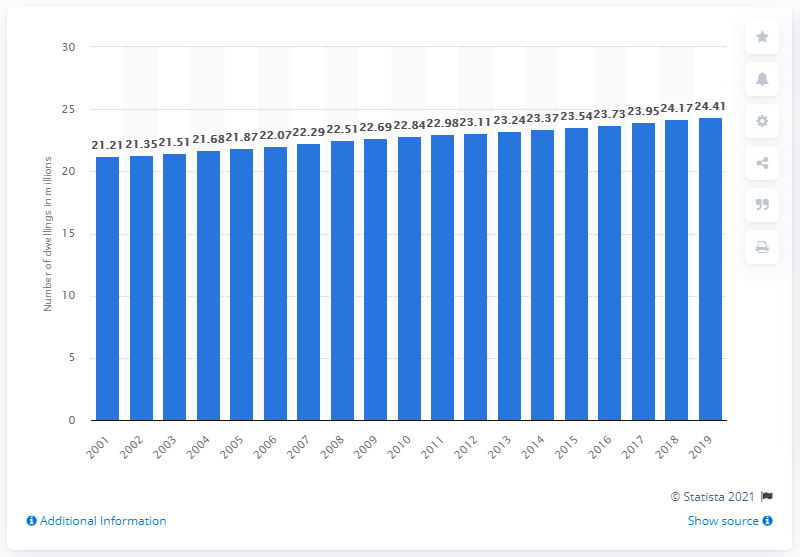List a handful of essential elements in this visual. As of 2018, there were 24.41 dwellings in England. 